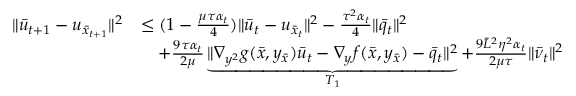Convert formula to latex. <formula><loc_0><loc_0><loc_500><loc_500>\begin{array} { r l } { \| \bar { u } _ { t + 1 } - u _ { \bar { x } _ { t + 1 } } \| ^ { 2 } } & { \leq ( 1 - \frac { \mu \tau \alpha _ { t } } { 4 } ) \| \bar { u } _ { t } - u _ { \bar { x } _ { t } } \| ^ { 2 } - \frac { \tau ^ { 2 } \alpha _ { t } } { 4 } \| \bar { q } _ { t } \| ^ { 2 } } \\ & { \quad + \frac { 9 \tau \alpha _ { t } } { 2 \mu } \underbrace { \| \nabla _ { y ^ { 2 } } g ( \bar { x } , y _ { \bar { x } } ) \bar { u } _ { t } - \nabla _ { y } f ( \bar { x } , y _ { \bar { x } } ) - \bar { q } _ { t } \| ^ { 2 } } _ { T _ { 1 } } + \frac { 9 \bar { L } ^ { 2 } \eta ^ { 2 } \alpha _ { t } } { 2 \mu \tau } \| \bar { \nu } _ { t } \| ^ { 2 } } \end{array}</formula> 